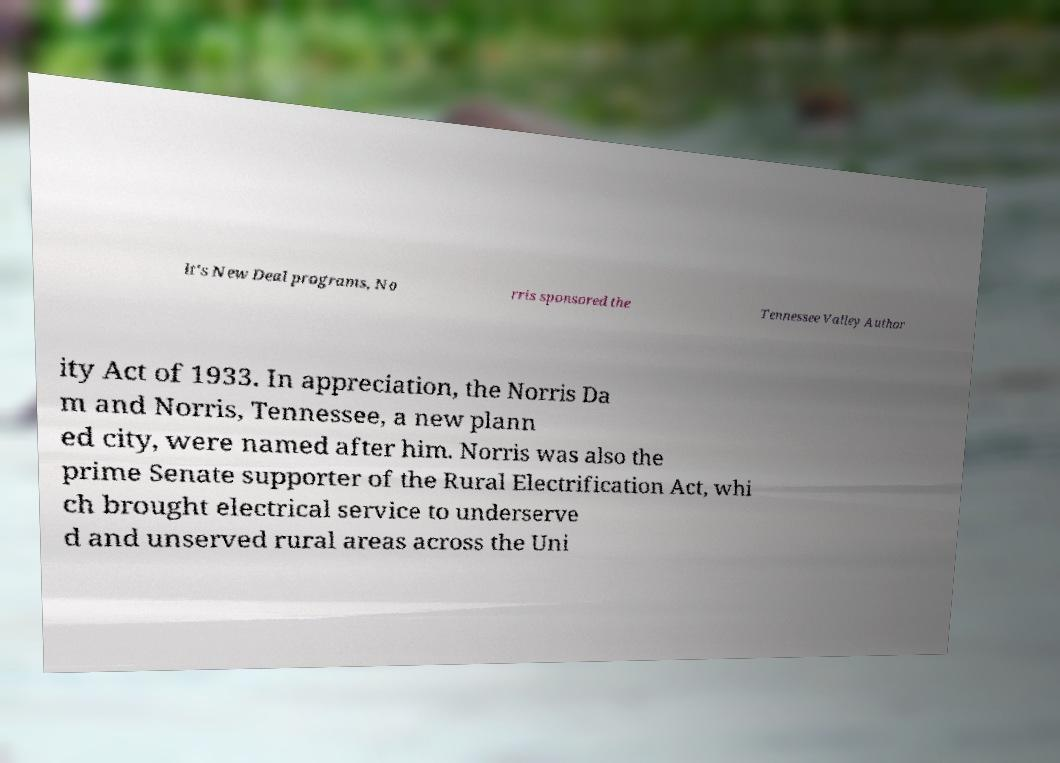Please identify and transcribe the text found in this image. lt's New Deal programs, No rris sponsored the Tennessee Valley Author ity Act of 1933. In appreciation, the Norris Da m and Norris, Tennessee, a new plann ed city, were named after him. Norris was also the prime Senate supporter of the Rural Electrification Act, whi ch brought electrical service to underserve d and unserved rural areas across the Uni 